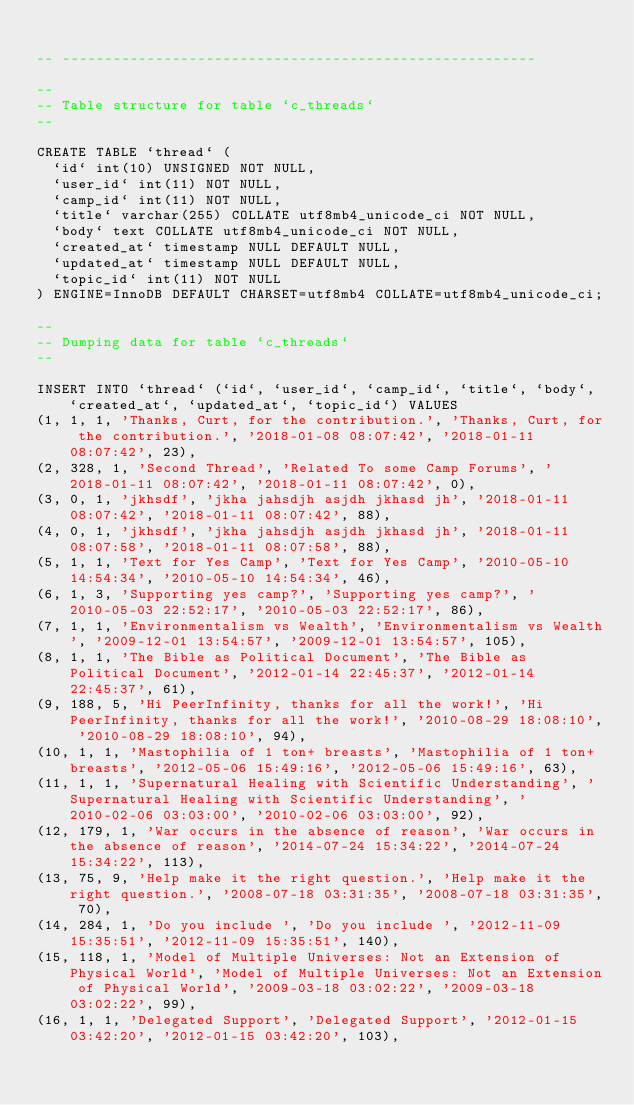<code> <loc_0><loc_0><loc_500><loc_500><_SQL_>
-- --------------------------------------------------------

--
-- Table structure for table `c_threads`
--

CREATE TABLE `thread` (
  `id` int(10) UNSIGNED NOT NULL,
  `user_id` int(11) NOT NULL,
  `camp_id` int(11) NOT NULL,
  `title` varchar(255) COLLATE utf8mb4_unicode_ci NOT NULL,
  `body` text COLLATE utf8mb4_unicode_ci NOT NULL,
  `created_at` timestamp NULL DEFAULT NULL,
  `updated_at` timestamp NULL DEFAULT NULL,
  `topic_id` int(11) NOT NULL
) ENGINE=InnoDB DEFAULT CHARSET=utf8mb4 COLLATE=utf8mb4_unicode_ci;

--
-- Dumping data for table `c_threads`
--

INSERT INTO `thread` (`id`, `user_id`, `camp_id`, `title`, `body`, `created_at`, `updated_at`, `topic_id`) VALUES
(1, 1, 1, 'Thanks, Curt, for the contribution.', 'Thanks, Curt, for the contribution.', '2018-01-08 08:07:42', '2018-01-11 08:07:42', 23),
(2, 328, 1, 'Second Thread', 'Related To some Camp Forums', '2018-01-11 08:07:42', '2018-01-11 08:07:42', 0),
(3, 0, 1, 'jkhsdf', 'jkha jahsdjh asjdh jkhasd jh', '2018-01-11 08:07:42', '2018-01-11 08:07:42', 88),
(4, 0, 1, 'jkhsdf', 'jkha jahsdjh asjdh jkhasd jh', '2018-01-11 08:07:58', '2018-01-11 08:07:58', 88),
(5, 1, 1, 'Text for Yes Camp', 'Text for Yes Camp', '2010-05-10 14:54:34', '2010-05-10 14:54:34', 46),
(6, 1, 3, 'Supporting yes camp?', 'Supporting yes camp?', '2010-05-03 22:52:17', '2010-05-03 22:52:17', 86),
(7, 1, 1, 'Environmentalism vs Wealth', 'Environmentalism vs Wealth', '2009-12-01 13:54:57', '2009-12-01 13:54:57', 105),
(8, 1, 1, 'The Bible as Political Document', 'The Bible as Political Document', '2012-01-14 22:45:37', '2012-01-14 22:45:37', 61),
(9, 188, 5, 'Hi PeerInfinity, thanks for all the work!', 'Hi PeerInfinity, thanks for all the work!', '2010-08-29 18:08:10', '2010-08-29 18:08:10', 94),
(10, 1, 1, 'Mastophilia of 1 ton+ breasts', 'Mastophilia of 1 ton+ breasts', '2012-05-06 15:49:16', '2012-05-06 15:49:16', 63),
(11, 1, 1, 'Supernatural Healing with Scientific Understanding', 'Supernatural Healing with Scientific Understanding', '2010-02-06 03:03:00', '2010-02-06 03:03:00', 92),
(12, 179, 1, 'War occurs in the absence of reason', 'War occurs in the absence of reason', '2014-07-24 15:34:22', '2014-07-24 15:34:22', 113),
(13, 75, 9, 'Help make it the right question.', 'Help make it the right question.', '2008-07-18 03:31:35', '2008-07-18 03:31:35', 70),
(14, 284, 1, 'Do you include ', 'Do you include ', '2012-11-09 15:35:51', '2012-11-09 15:35:51', 140),
(15, 118, 1, 'Model of Multiple Universes: Not an Extension of Physical World', 'Model of Multiple Universes: Not an Extension of Physical World', '2009-03-18 03:02:22', '2009-03-18 03:02:22', 99),
(16, 1, 1, 'Delegated Support', 'Delegated Support', '2012-01-15 03:42:20', '2012-01-15 03:42:20', 103),</code> 